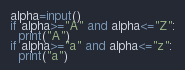Convert code to text. <code><loc_0><loc_0><loc_500><loc_500><_Python_>alpha=input()
if alpha>="A" and alpha<="Z":
  print("A")
if alpha>="a" and alpha<="z":
  print("a")    </code> 